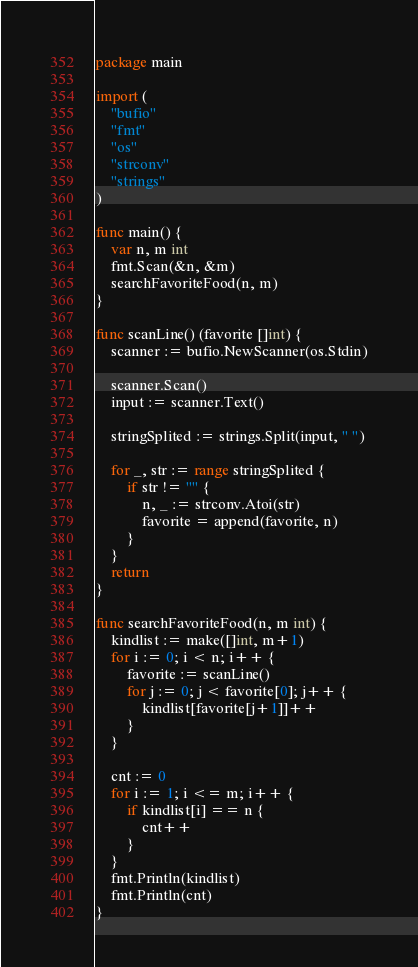<code> <loc_0><loc_0><loc_500><loc_500><_Go_>package main

import (
	"bufio"
	"fmt"
	"os"
	"strconv"
	"strings"
)

func main() {
	var n, m int
	fmt.Scan(&n, &m)
	searchFavoriteFood(n, m)
}

func scanLine() (favorite []int) {
	scanner := bufio.NewScanner(os.Stdin)

	scanner.Scan()
	input := scanner.Text()

	stringSplited := strings.Split(input, " ")

	for _, str := range stringSplited {
		if str != "" {
			n, _ := strconv.Atoi(str)
			favorite = append(favorite, n)
		}
	}
	return
}

func searchFavoriteFood(n, m int) {
	kindlist := make([]int, m+1)
	for i := 0; i < n; i++ {
		favorite := scanLine()
		for j := 0; j < favorite[0]; j++ {
			kindlist[favorite[j+1]]++
		}
	}

	cnt := 0
	for i := 1; i <= m; i++ {
		if kindlist[i] == n {
			cnt++
		}
	}
	fmt.Println(kindlist)
	fmt.Println(cnt)
}
</code> 